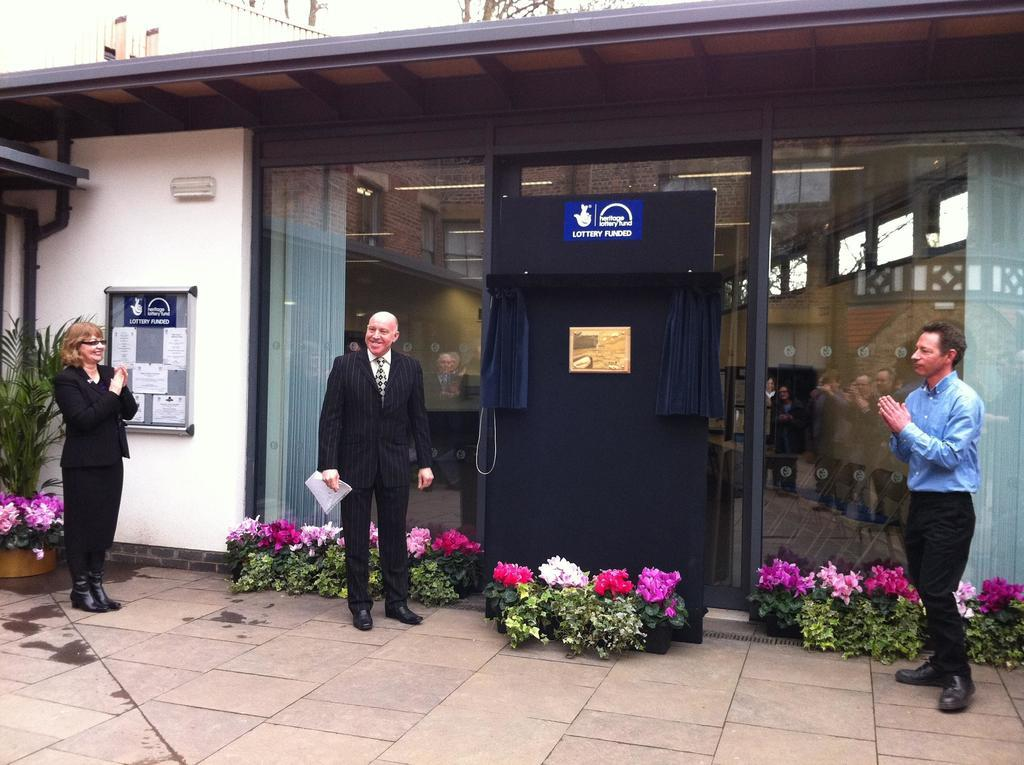<image>
Write a terse but informative summary of the picture. Three people stand outside a building for the Heritage Lottery Fund. 